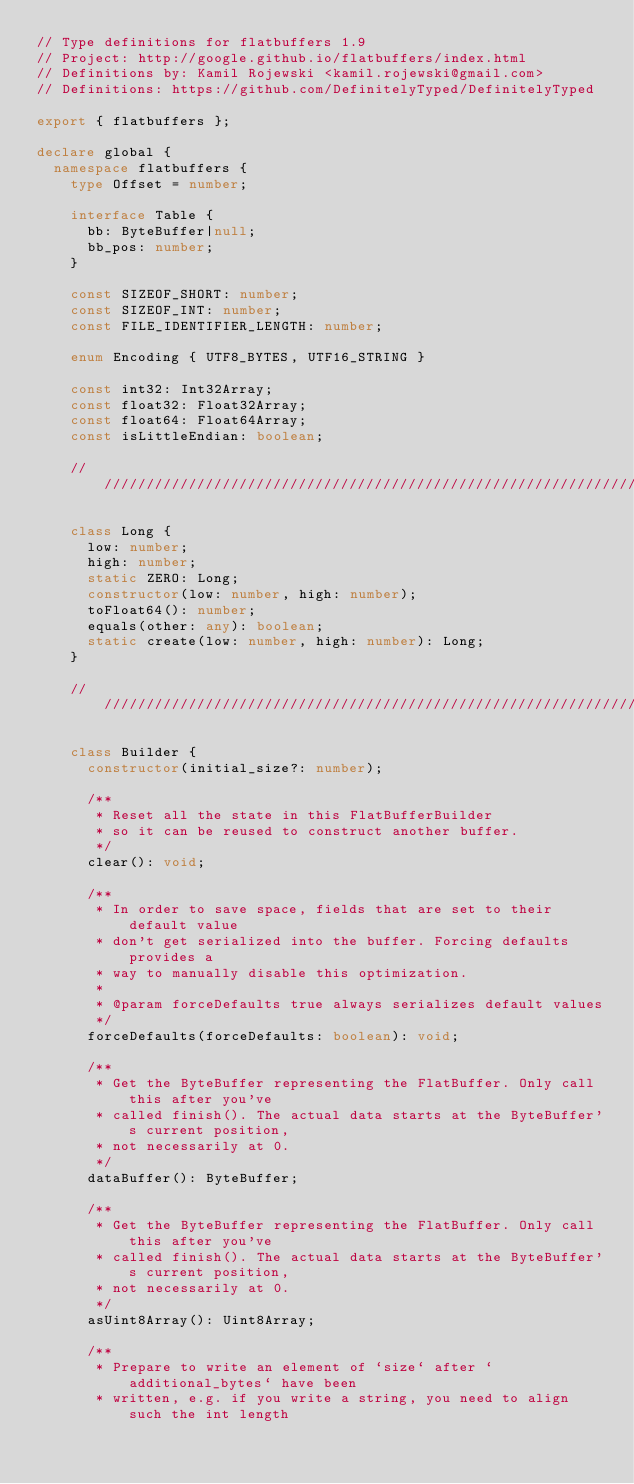Convert code to text. <code><loc_0><loc_0><loc_500><loc_500><_TypeScript_>// Type definitions for flatbuffers 1.9
// Project: http://google.github.io/flatbuffers/index.html
// Definitions by: Kamil Rojewski <kamil.rojewski@gmail.com>
// Definitions: https://github.com/DefinitelyTyped/DefinitelyTyped

export { flatbuffers };

declare global {
  namespace flatbuffers {
    type Offset = number;

    interface Table {
      bb: ByteBuffer|null;
      bb_pos: number;
    }

    const SIZEOF_SHORT: number;
    const SIZEOF_INT: number;
    const FILE_IDENTIFIER_LENGTH: number;

    enum Encoding { UTF8_BYTES, UTF16_STRING }

    const int32: Int32Array;
    const float32: Float32Array;
    const float64: Float64Array;
    const isLittleEndian: boolean;

    ////////////////////////////////////////////////////////////////////////////////

    class Long {
      low: number;
      high: number;
      static ZERO: Long;
      constructor(low: number, high: number);
      toFloat64(): number;
      equals(other: any): boolean;
      static create(low: number, high: number): Long;
    }

    ////////////////////////////////////////////////////////////////////////////////

    class Builder {
      constructor(initial_size?: number);

      /**
       * Reset all the state in this FlatBufferBuilder
       * so it can be reused to construct another buffer.
       */
      clear(): void;

      /**
       * In order to save space, fields that are set to their default value
       * don't get serialized into the buffer. Forcing defaults provides a
       * way to manually disable this optimization.
       *
       * @param forceDefaults true always serializes default values
       */
      forceDefaults(forceDefaults: boolean): void;

      /**
       * Get the ByteBuffer representing the FlatBuffer. Only call this after you've
       * called finish(). The actual data starts at the ByteBuffer's current position,
       * not necessarily at 0.
       */
      dataBuffer(): ByteBuffer;

      /**
       * Get the ByteBuffer representing the FlatBuffer. Only call this after you've
       * called finish(). The actual data starts at the ByteBuffer's current position,
       * not necessarily at 0.
       */
      asUint8Array(): Uint8Array;

      /**
       * Prepare to write an element of `size` after `additional_bytes` have been
       * written, e.g. if you write a string, you need to align such the int length</code> 